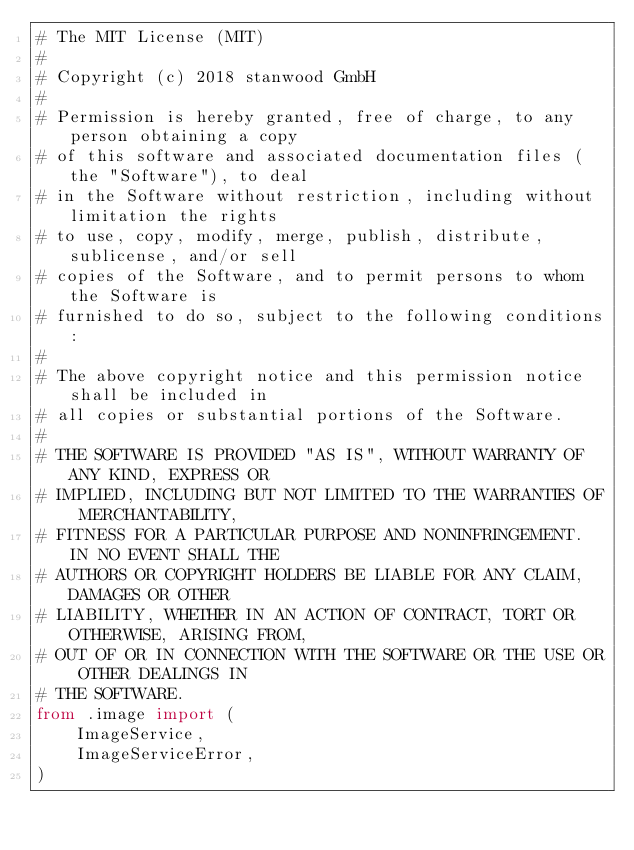<code> <loc_0><loc_0><loc_500><loc_500><_Python_># The MIT License (MIT)
# 
# Copyright (c) 2018 stanwood GmbH
# 
# Permission is hereby granted, free of charge, to any person obtaining a copy
# of this software and associated documentation files (the "Software"), to deal
# in the Software without restriction, including without limitation the rights
# to use, copy, modify, merge, publish, distribute, sublicense, and/or sell
# copies of the Software, and to permit persons to whom the Software is
# furnished to do so, subject to the following conditions:
# 
# The above copyright notice and this permission notice shall be included in
# all copies or substantial portions of the Software.
# 
# THE SOFTWARE IS PROVIDED "AS IS", WITHOUT WARRANTY OF ANY KIND, EXPRESS OR
# IMPLIED, INCLUDING BUT NOT LIMITED TO THE WARRANTIES OF MERCHANTABILITY,
# FITNESS FOR A PARTICULAR PURPOSE AND NONINFRINGEMENT. IN NO EVENT SHALL THE
# AUTHORS OR COPYRIGHT HOLDERS BE LIABLE FOR ANY CLAIM, DAMAGES OR OTHER
# LIABILITY, WHETHER IN AN ACTION OF CONTRACT, TORT OR OTHERWISE, ARISING FROM,
# OUT OF OR IN CONNECTION WITH THE SOFTWARE OR THE USE OR OTHER DEALINGS IN
# THE SOFTWARE.
from .image import (
    ImageService,
    ImageServiceError,
)
</code> 